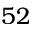Convert formula to latex. <formula><loc_0><loc_0><loc_500><loc_500>5 2</formula> 